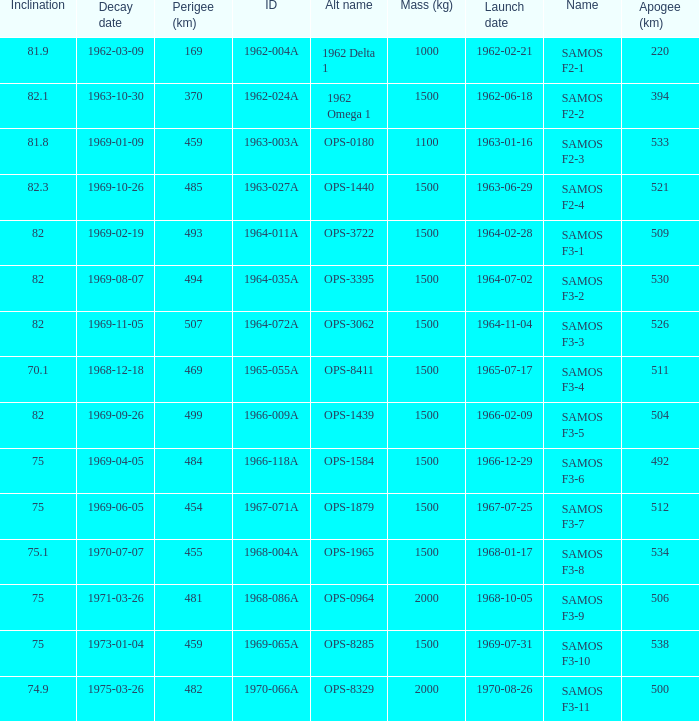What is the inclination when the alt name is OPS-1584? 75.0. 